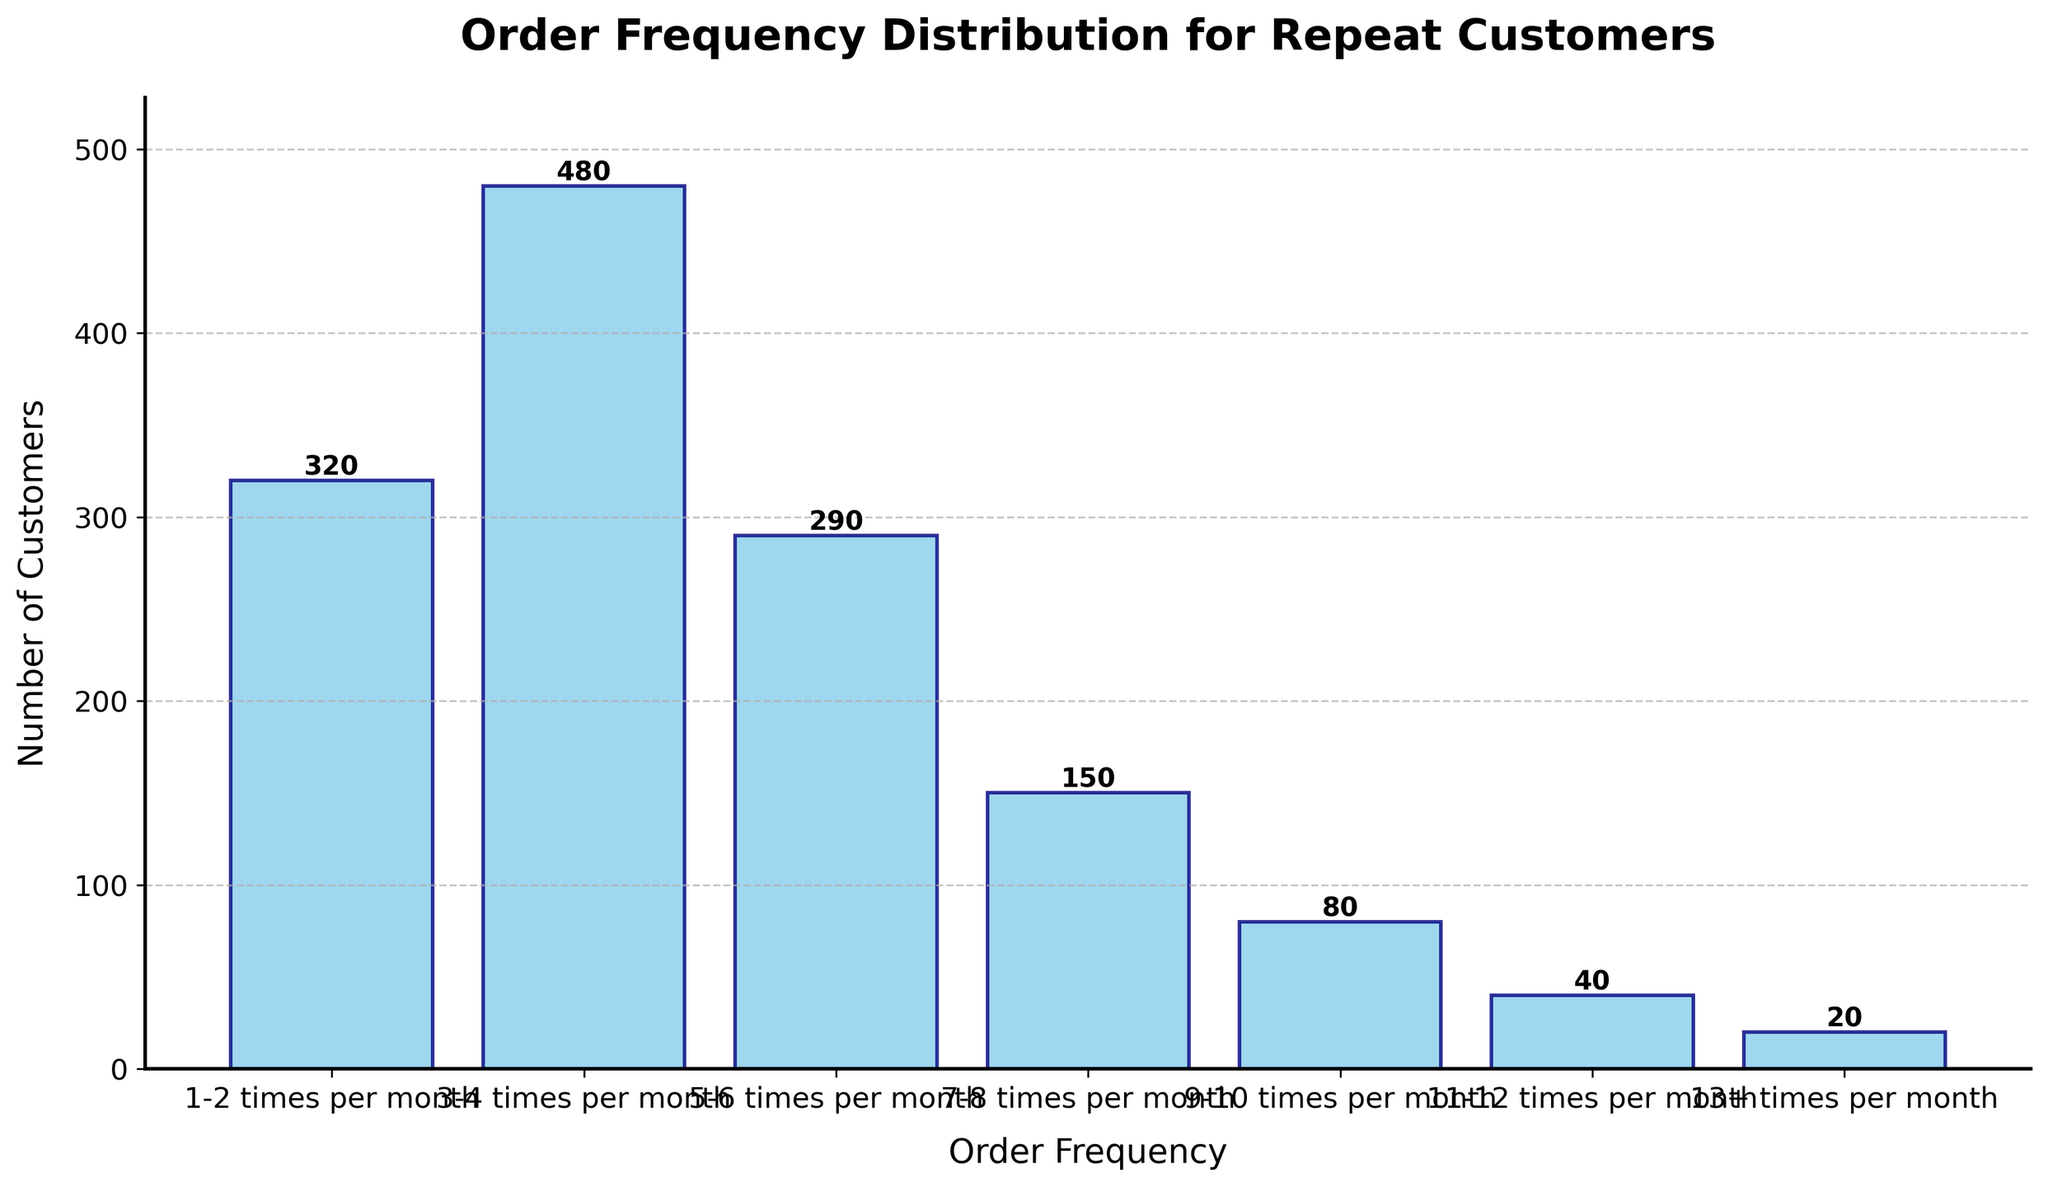What is the title of the figure? The title can be found at the top of the figure, indicating what the histogram represents. It is written in bold and larger font size to stand out.
Answer: Order Frequency Distribution for Repeat Customers How many customers order 5-6 times per month? To find this number, look at the bar corresponding to the 5-6 times per month category. The height of the bar represents the number of customers, and the exact number is written above the bar.
Answer: 290 Which order frequency category has the highest number of customers? Observe the height of the bars. The tallest bar represents the category with the highest number of customers. From the text labels above each bar, you can confirm the exact number.
Answer: 3-4 times per month How many customers order between 9 and 12 times per month? Sum the values of the bars representing the 9-10 times and 11-12 times per month categories. 80 customers order 9-10 times, and 40 customers order 11-12 times. Adding these gives the total.
Answer: 120 What is the range of the y-axis in this plot? The range of the y-axis is defined from 0 to the maximum value represented by the highest bar plus a bit more for visual clarity. The highest bar is 480, so the maximum value is slightly above this.
Answer: 0 to around 530 How does the number of customers ordering 7-8 times per month compare to the number of customers ordering 1-2 times per month? Compare the heights of the two bars. The bar for 1-2 times per month is 320, while the bar for 7-8 times per month is 150.
Answer: 7-8 times per month is less than 1-2 times per month What is the total number of customers represented in the histogram? Add the number of customers for all order frequency categories: 320 + 480 + 290 + 150 + 80 + 40 + 20. This totals to the overall number of customers.
Answer: 1380 Which order frequency category has the lowest number of customers? Observe the shortest bar in the histogram, which represents the category with the lowest number of customers. The label above it indicates the exact number.
Answer: 13+ times per month 